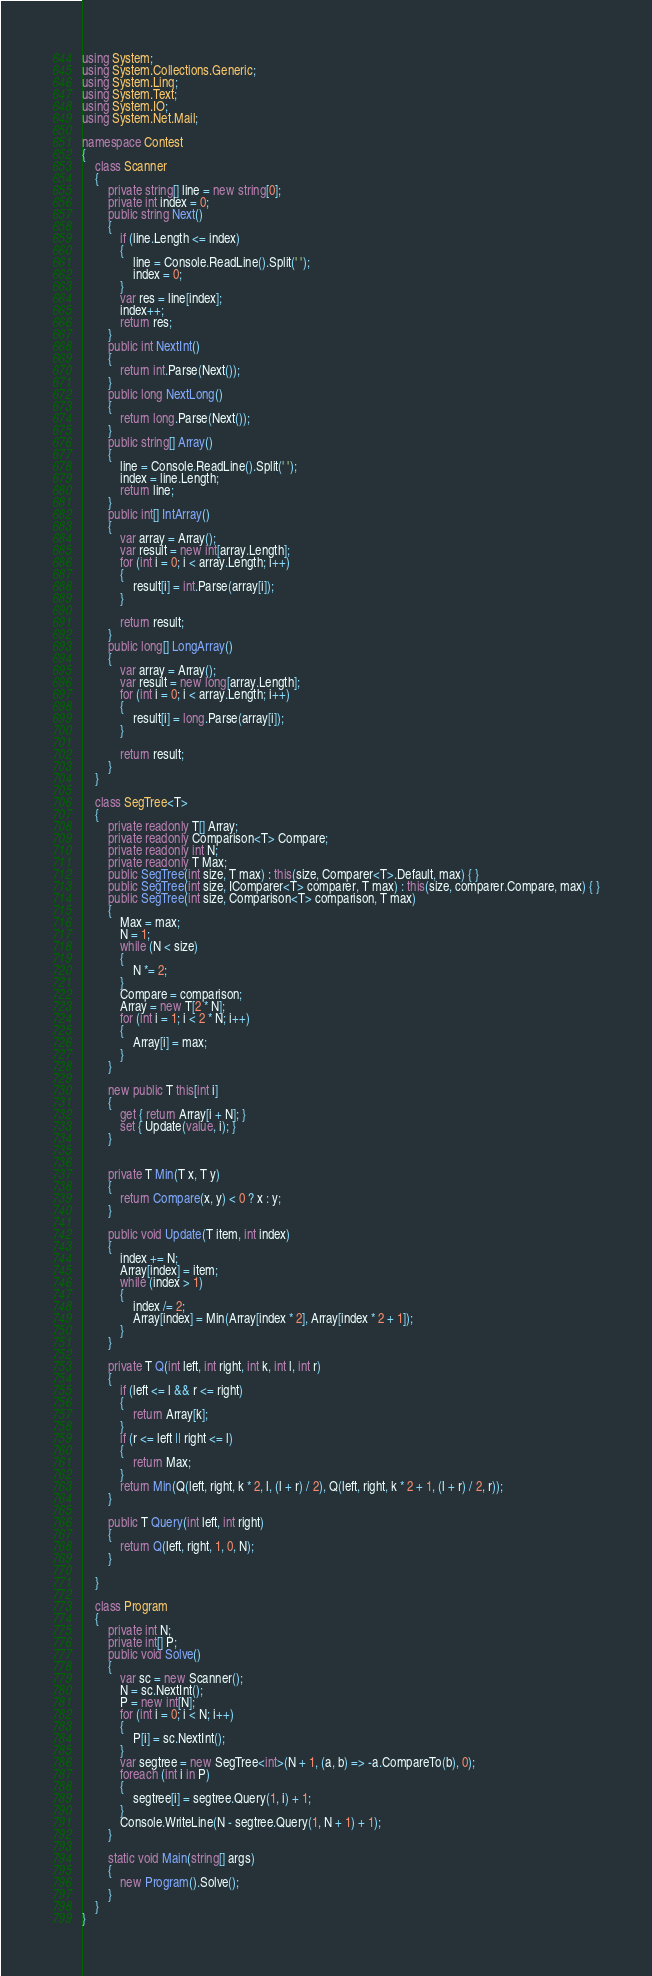Convert code to text. <code><loc_0><loc_0><loc_500><loc_500><_C#_>using System;
using System.Collections.Generic;
using System.Linq;
using System.Text;
using System.IO;
using System.Net.Mail;

namespace Contest
{
    class Scanner
    {
        private string[] line = new string[0];
        private int index = 0;
        public string Next()
        {
            if (line.Length <= index)
            {
                line = Console.ReadLine().Split(' ');
                index = 0;
            }
            var res = line[index];
            index++;
            return res;
        }
        public int NextInt()
        {
            return int.Parse(Next());
        }
        public long NextLong()
        {
            return long.Parse(Next());
        }
        public string[] Array()
        {
            line = Console.ReadLine().Split(' ');
            index = line.Length;
            return line;
        }
        public int[] IntArray()
        {
            var array = Array();
            var result = new int[array.Length];
            for (int i = 0; i < array.Length; i++)
            {
                result[i] = int.Parse(array[i]);
            }

            return result;
        }
        public long[] LongArray()
        {
            var array = Array();
            var result = new long[array.Length];
            for (int i = 0; i < array.Length; i++)
            {
                result[i] = long.Parse(array[i]);
            }

            return result;
        }
    }

    class SegTree<T>
    {
        private readonly T[] Array;
        private readonly Comparison<T> Compare;
        private readonly int N;
        private readonly T Max;
        public SegTree(int size, T max) : this(size, Comparer<T>.Default, max) { }
        public SegTree(int size, IComparer<T> comparer, T max) : this(size, comparer.Compare, max) { }
        public SegTree(int size, Comparison<T> comparison, T max)
        {
            Max = max;
            N = 1;
            while (N < size)
            {
                N *= 2;
            }
            Compare = comparison;
            Array = new T[2 * N];
            for (int i = 1; i < 2 * N; i++)
            {
                Array[i] = max;
            }
        }

        new public T this[int i]
        {
            get { return Array[i + N]; }
            set { Update(value, i); }
        }


        private T Min(T x, T y)
        {
            return Compare(x, y) < 0 ? x : y;
        }

        public void Update(T item, int index)
        {
            index += N;
            Array[index] = item;
            while (index > 1)
            {
                index /= 2;
                Array[index] = Min(Array[index * 2], Array[index * 2 + 1]);
            }
        }

        private T Q(int left, int right, int k, int l, int r)
        {
            if (left <= l && r <= right)
            {
                return Array[k];
            }
            if (r <= left || right <= l)
            {
                return Max;
            }
            return Min(Q(left, right, k * 2, l, (l + r) / 2), Q(left, right, k * 2 + 1, (l + r) / 2, r));
        }

        public T Query(int left, int right)
        {
            return Q(left, right, 1, 0, N);
        }

    }

    class Program
    {
        private int N;
        private int[] P;
        public void Solve()
        {
            var sc = new Scanner();
            N = sc.NextInt();
            P = new int[N];
            for (int i = 0; i < N; i++)
            {
                P[i] = sc.NextInt();
            }
            var segtree = new SegTree<int>(N + 1, (a, b) => -a.CompareTo(b), 0);
            foreach (int i in P)
            {
                segtree[i] = segtree.Query(1, i) + 1;
            }
            Console.WriteLine(N - segtree.Query(1, N + 1) + 1);
        }

        static void Main(string[] args)
        {
            new Program().Solve();
        }
    }
}</code> 